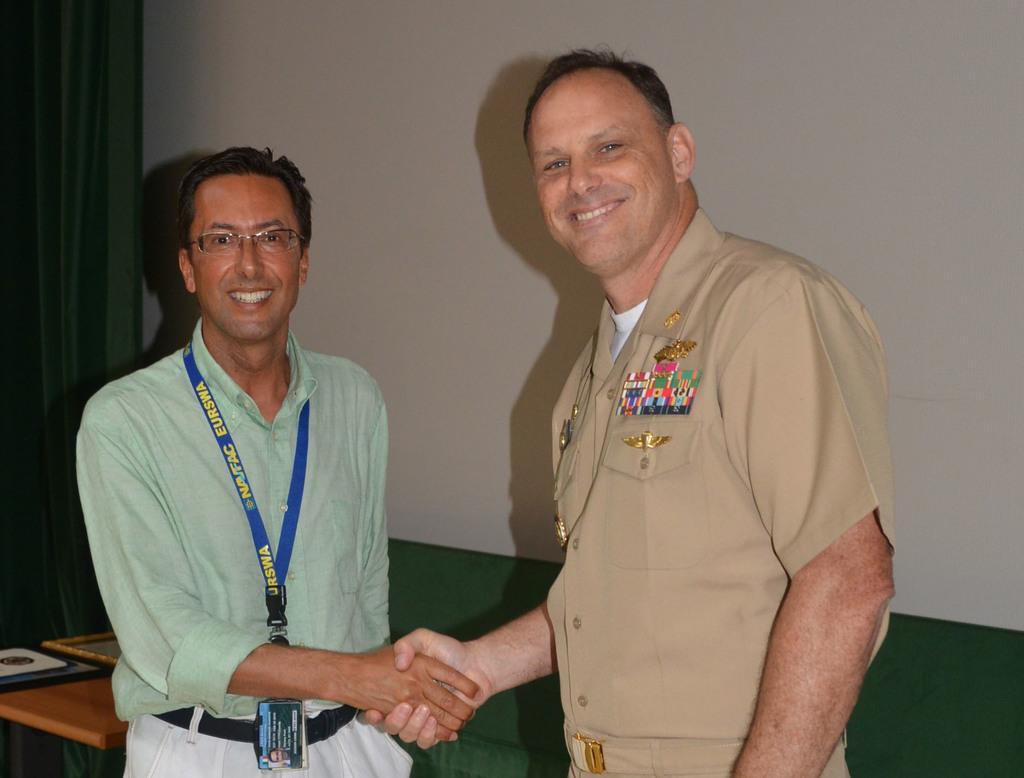How many people are in the image? There are people in the image, but the exact number is not specified. What is the curtain used for in the image? The purpose of the curtain is not clear from the image, but it could be used for privacy or decoration. What is the object at the bottom of the image? The object at the bottom of the image is not described in detail, so it is difficult to identify what it is. What information can be gathered about the person wearing an identity card in the image? The person in the image is wearing an identity card, which suggests they may be in a professional or institutional setting. What type of calculator is being used by the minister in the image? There is no minister or calculator present in the image. 